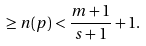<formula> <loc_0><loc_0><loc_500><loc_500>\geq n ( p ) < \frac { m + 1 } { s + 1 } + 1 .</formula> 